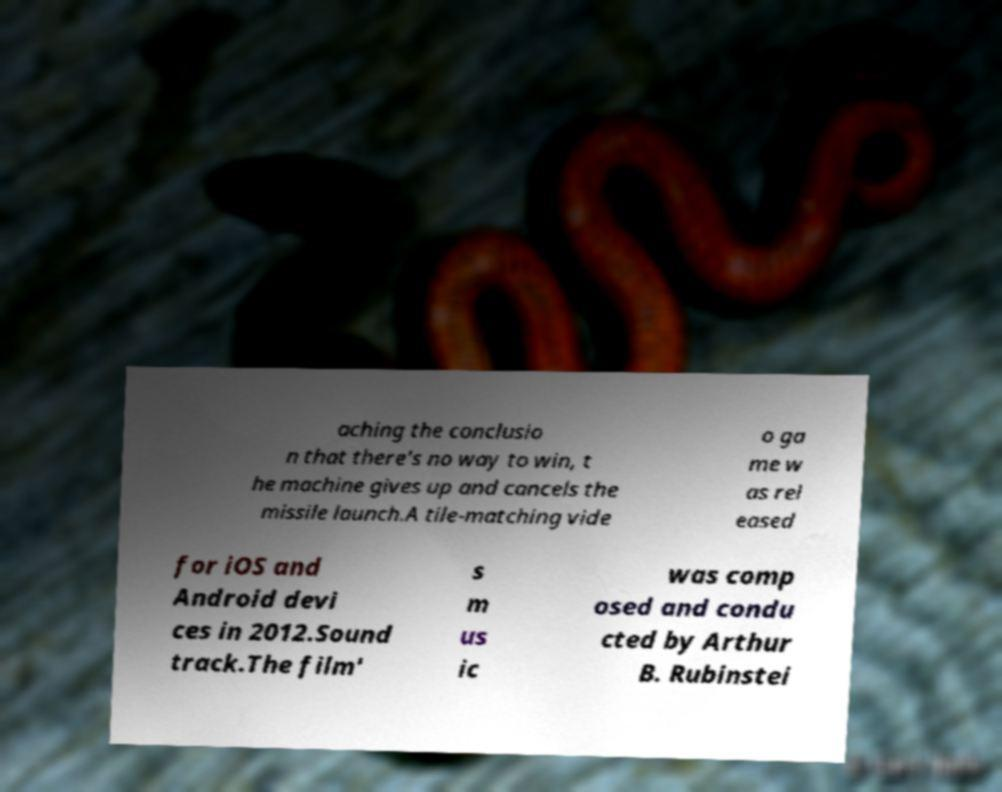What messages or text are displayed in this image? I need them in a readable, typed format. aching the conclusio n that there's no way to win, t he machine gives up and cancels the missile launch.A tile-matching vide o ga me w as rel eased for iOS and Android devi ces in 2012.Sound track.The film' s m us ic was comp osed and condu cted by Arthur B. Rubinstei 